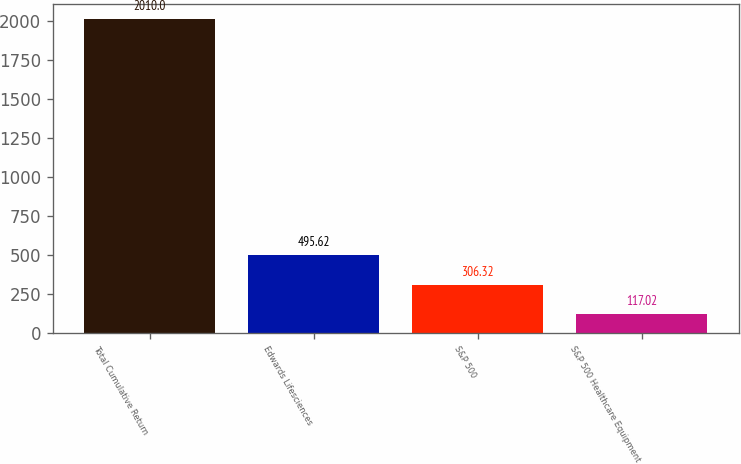<chart> <loc_0><loc_0><loc_500><loc_500><bar_chart><fcel>Total Cumulative Return<fcel>Edwards Lifesciences<fcel>S&P 500<fcel>S&P 500 Healthcare Equipment<nl><fcel>2010<fcel>495.62<fcel>306.32<fcel>117.02<nl></chart> 